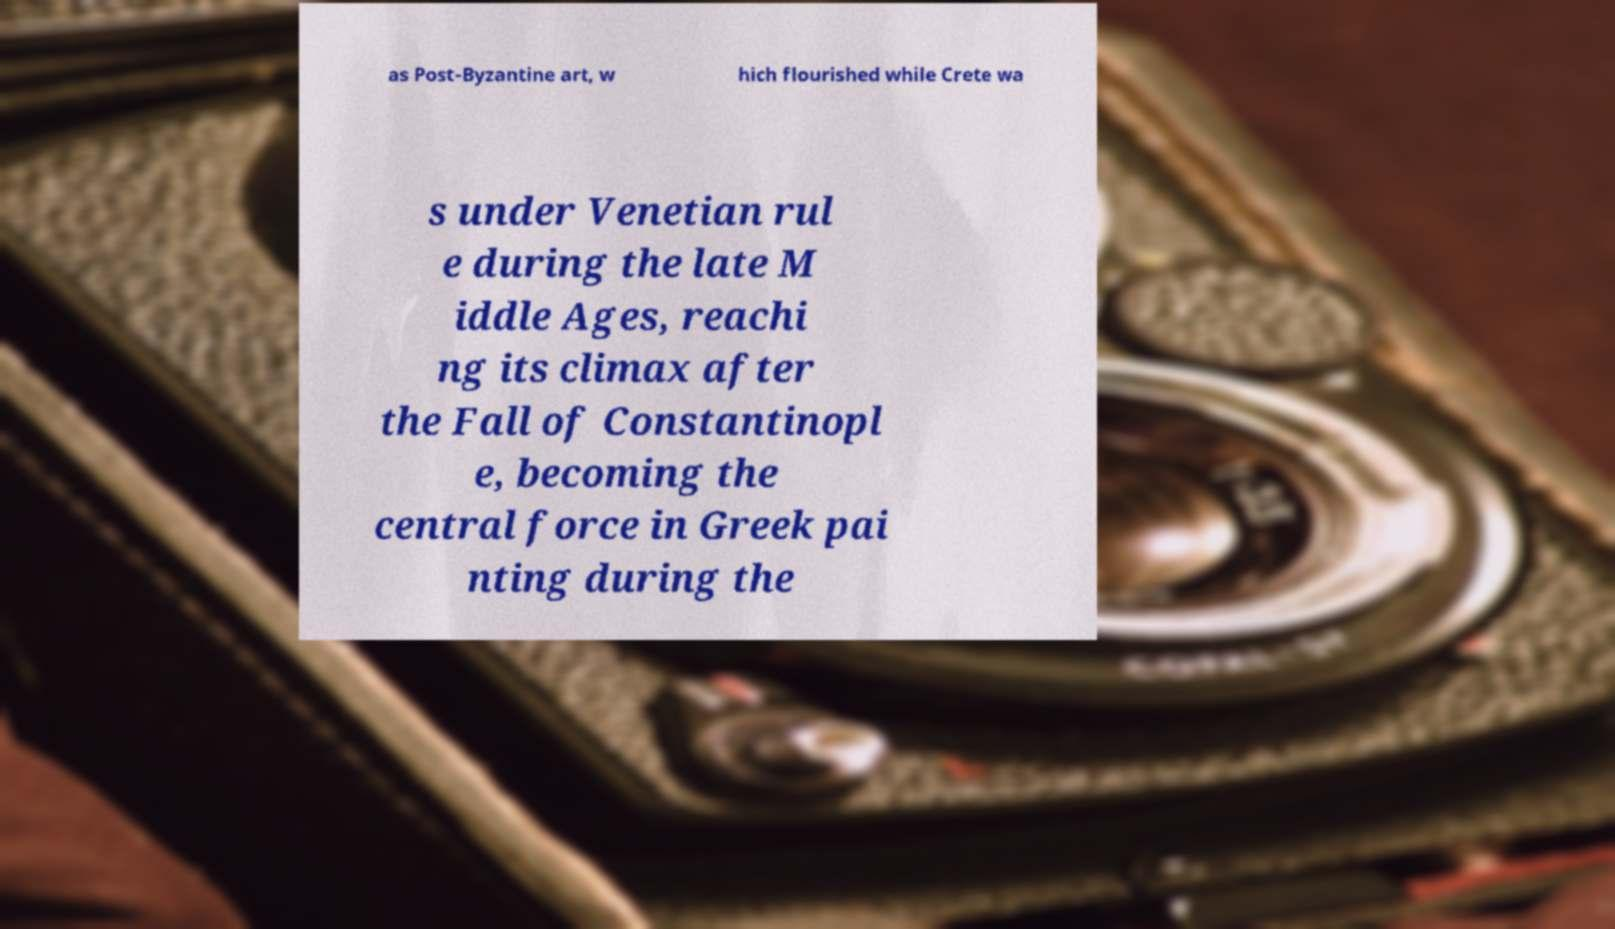I need the written content from this picture converted into text. Can you do that? as Post-Byzantine art, w hich flourished while Crete wa s under Venetian rul e during the late M iddle Ages, reachi ng its climax after the Fall of Constantinopl e, becoming the central force in Greek pai nting during the 